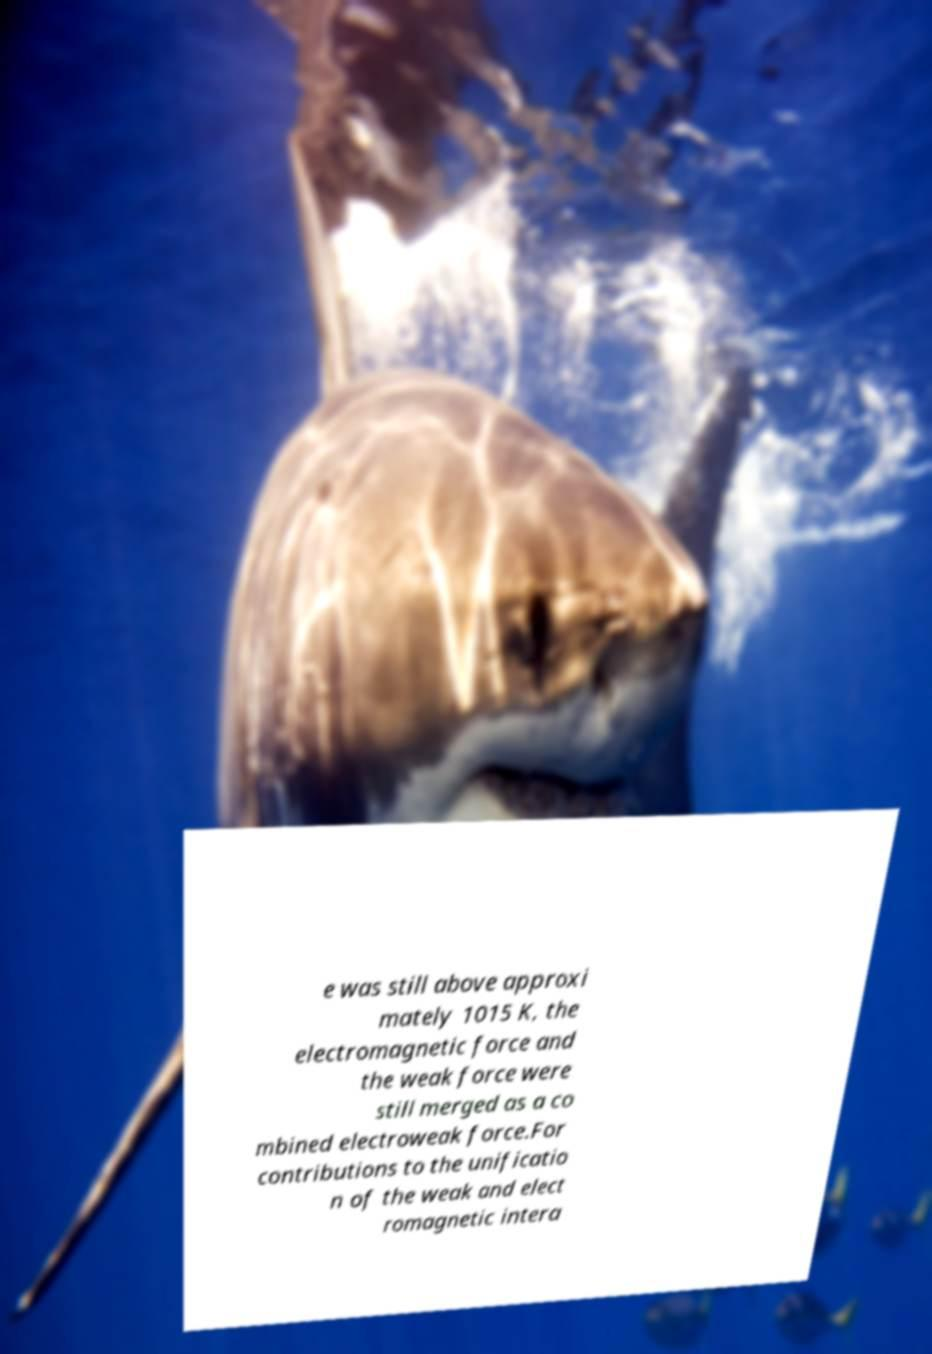Could you assist in decoding the text presented in this image and type it out clearly? e was still above approxi mately 1015 K, the electromagnetic force and the weak force were still merged as a co mbined electroweak force.For contributions to the unificatio n of the weak and elect romagnetic intera 